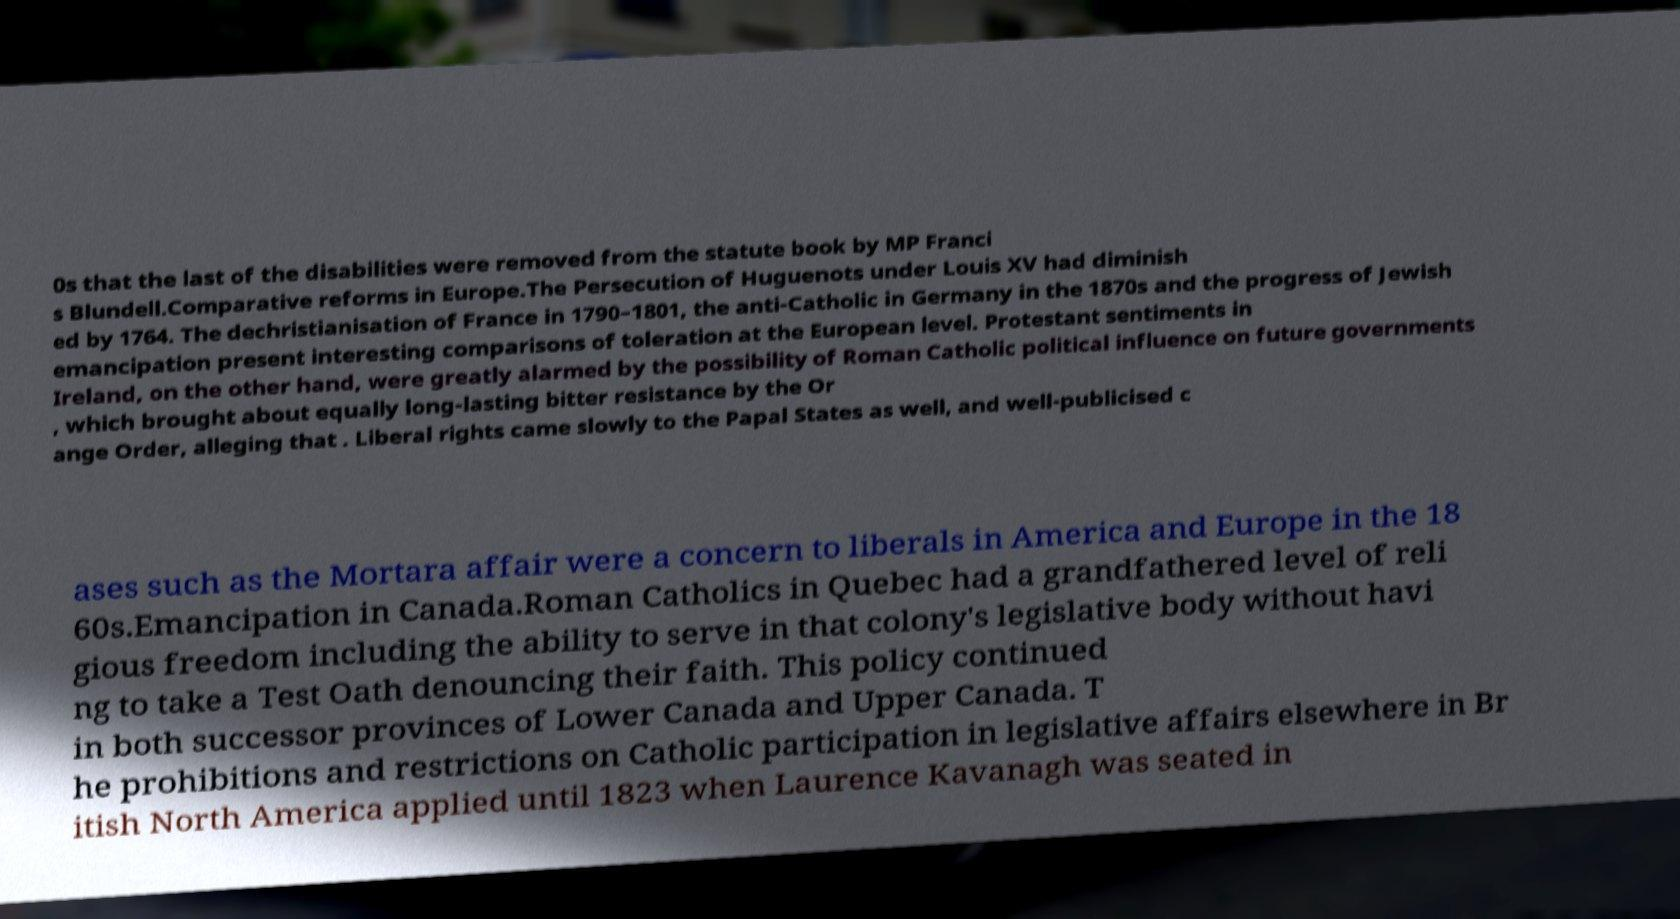Could you assist in decoding the text presented in this image and type it out clearly? 0s that the last of the disabilities were removed from the statute book by MP Franci s Blundell.Comparative reforms in Europe.The Persecution of Huguenots under Louis XV had diminish ed by 1764. The dechristianisation of France in 1790–1801, the anti-Catholic in Germany in the 1870s and the progress of Jewish emancipation present interesting comparisons of toleration at the European level. Protestant sentiments in Ireland, on the other hand, were greatly alarmed by the possibility of Roman Catholic political influence on future governments , which brought about equally long-lasting bitter resistance by the Or ange Order, alleging that . Liberal rights came slowly to the Papal States as well, and well-publicised c ases such as the Mortara affair were a concern to liberals in America and Europe in the 18 60s.Emancipation in Canada.Roman Catholics in Quebec had a grandfathered level of reli gious freedom including the ability to serve in that colony's legislative body without havi ng to take a Test Oath denouncing their faith. This policy continued in both successor provinces of Lower Canada and Upper Canada. T he prohibitions and restrictions on Catholic participation in legislative affairs elsewhere in Br itish North America applied until 1823 when Laurence Kavanagh was seated in 